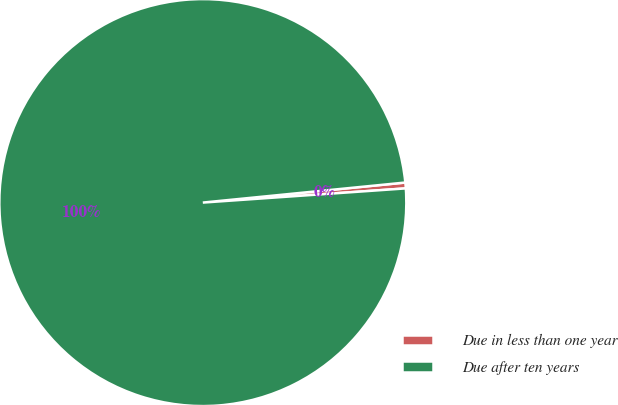Convert chart. <chart><loc_0><loc_0><loc_500><loc_500><pie_chart><fcel>Due in less than one year<fcel>Due after ten years<nl><fcel>0.46%<fcel>99.54%<nl></chart> 